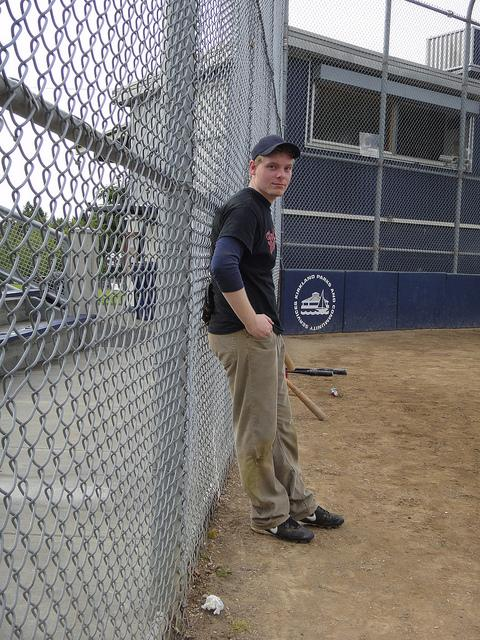What is he doing?

Choices:
A) posing
B) drinking
C) eating
D) playing baseball posing 